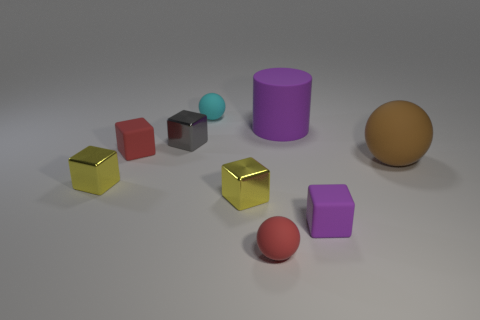Subtract all brown cubes. Subtract all brown balls. How many cubes are left? 5 Add 1 tiny balls. How many objects exist? 10 Subtract all blocks. How many objects are left? 4 Add 8 purple matte cylinders. How many purple matte cylinders exist? 9 Subtract 0 yellow spheres. How many objects are left? 9 Subtract all tiny yellow matte cylinders. Subtract all matte cylinders. How many objects are left? 8 Add 8 small red rubber blocks. How many small red rubber blocks are left? 9 